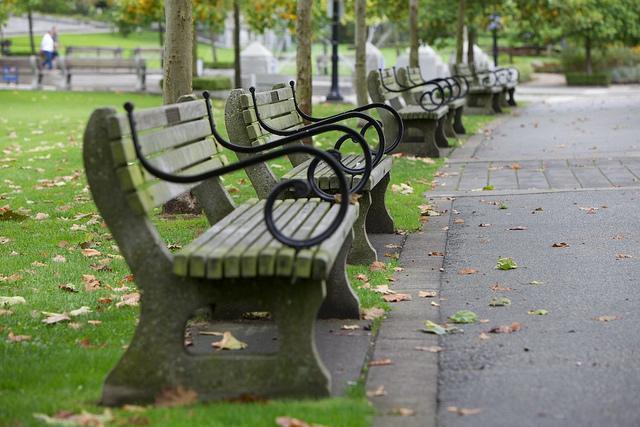What is on the grass?
Select the accurate answer and provide explanation: 'Answer: answer
Rationale: rationale.'
Options: Antelope, cow, baby, bench. Answer: bench.
Rationale: There are no humans or animals on the grass. there are objects for sitting. 